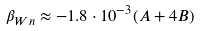<formula> <loc_0><loc_0><loc_500><loc_500>\beta _ { W n } \approx - 1 . 8 \cdot 1 0 ^ { - 3 } ( A + 4 B )</formula> 